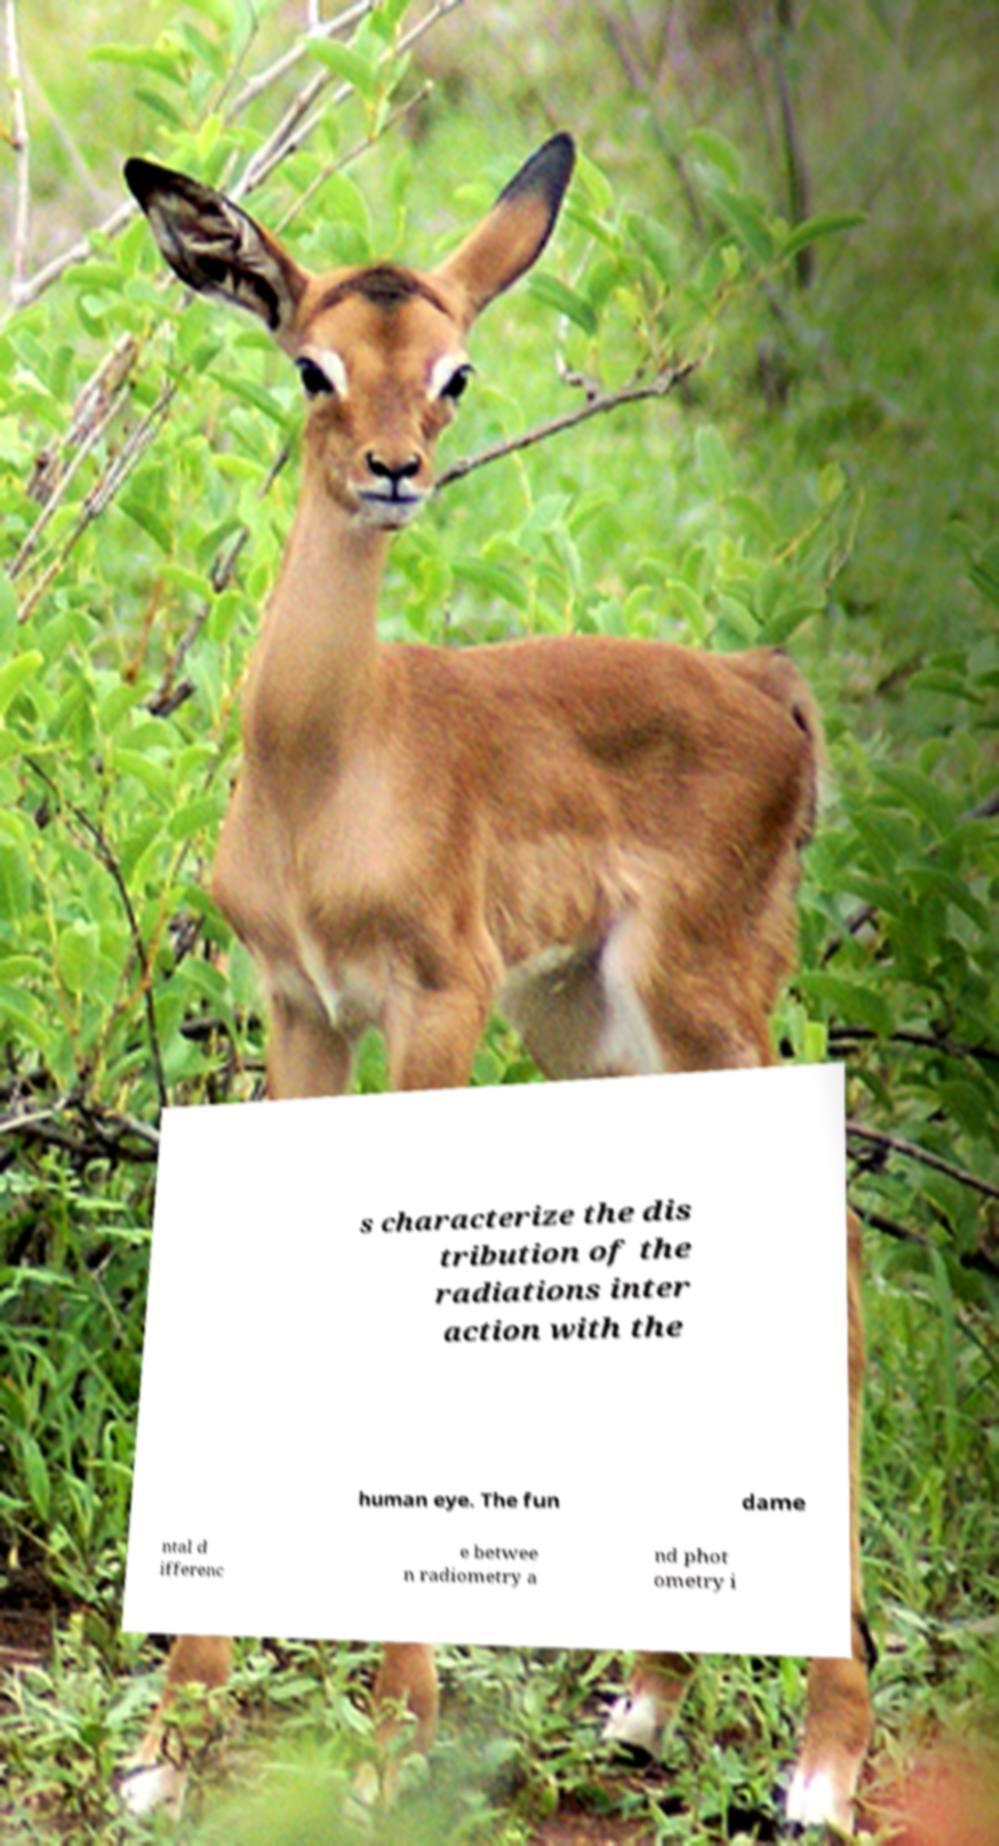Could you extract and type out the text from this image? s characterize the dis tribution of the radiations inter action with the human eye. The fun dame ntal d ifferenc e betwee n radiometry a nd phot ometry i 